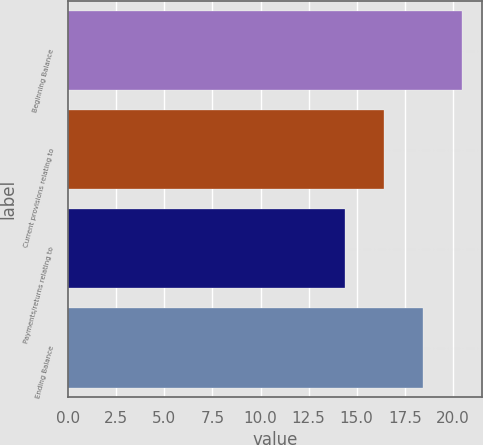Convert chart to OTSL. <chart><loc_0><loc_0><loc_500><loc_500><bar_chart><fcel>Beginning Balance<fcel>Current provisions relating to<fcel>Payments/returns relating to<fcel>Ending Balance<nl><fcel>20.49<fcel>16.43<fcel>14.4<fcel>18.46<nl></chart> 